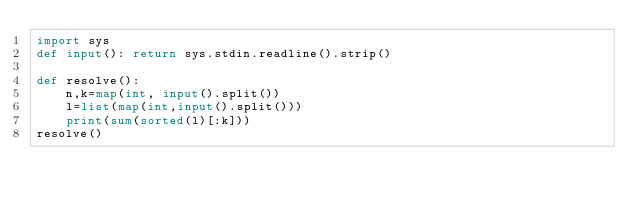<code> <loc_0><loc_0><loc_500><loc_500><_Python_>import sys
def input(): return sys.stdin.readline().strip()

def resolve():
    n,k=map(int, input().split())
    l=list(map(int,input().split()))
    print(sum(sorted(l)[:k]))
resolve()
</code> 